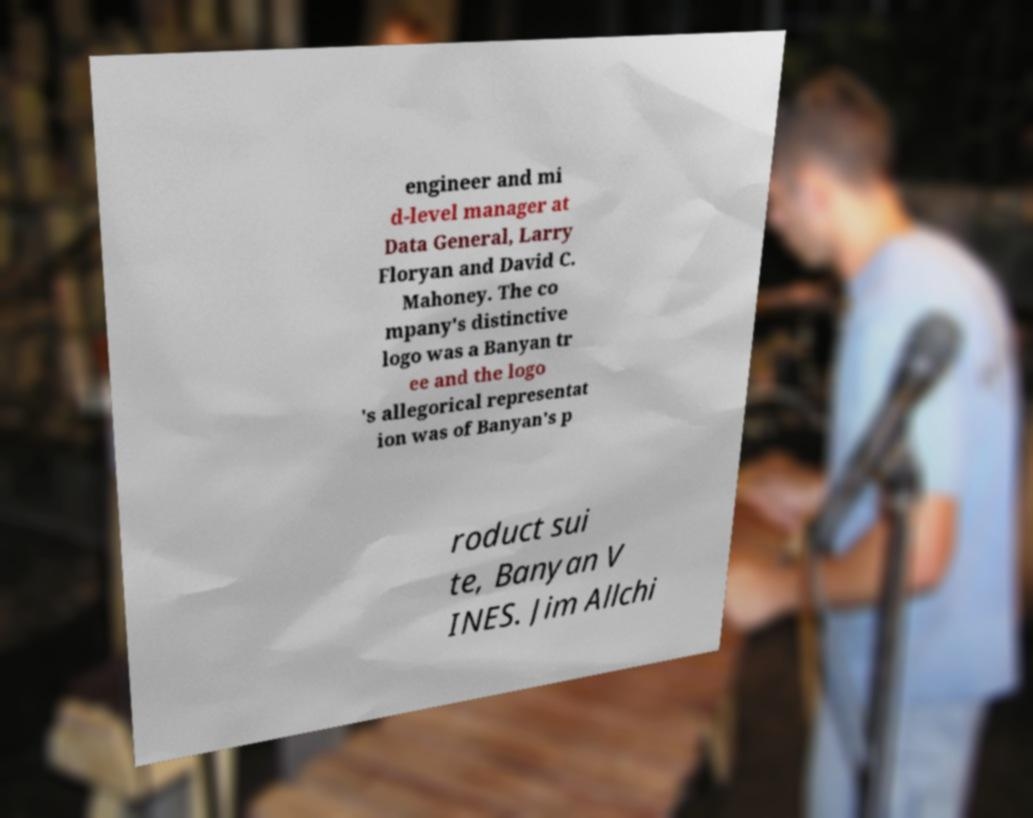Could you extract and type out the text from this image? engineer and mi d-level manager at Data General, Larry Floryan and David C. Mahoney. The co mpany's distinctive logo was a Banyan tr ee and the logo 's allegorical representat ion was of Banyan's p roduct sui te, Banyan V INES. Jim Allchi 